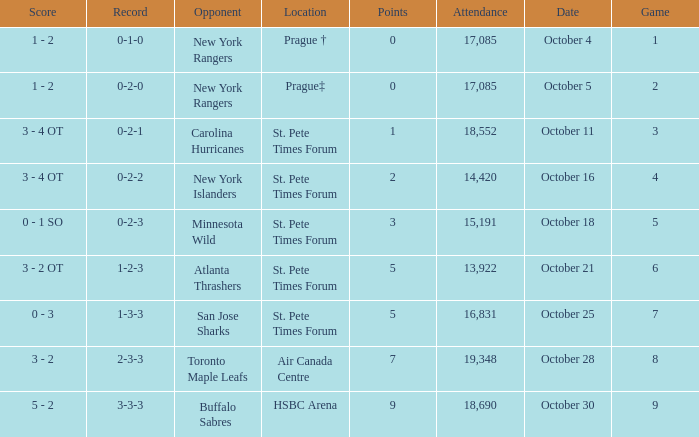What was the attendance when their record stood at 0-2-2? 14420.0. 